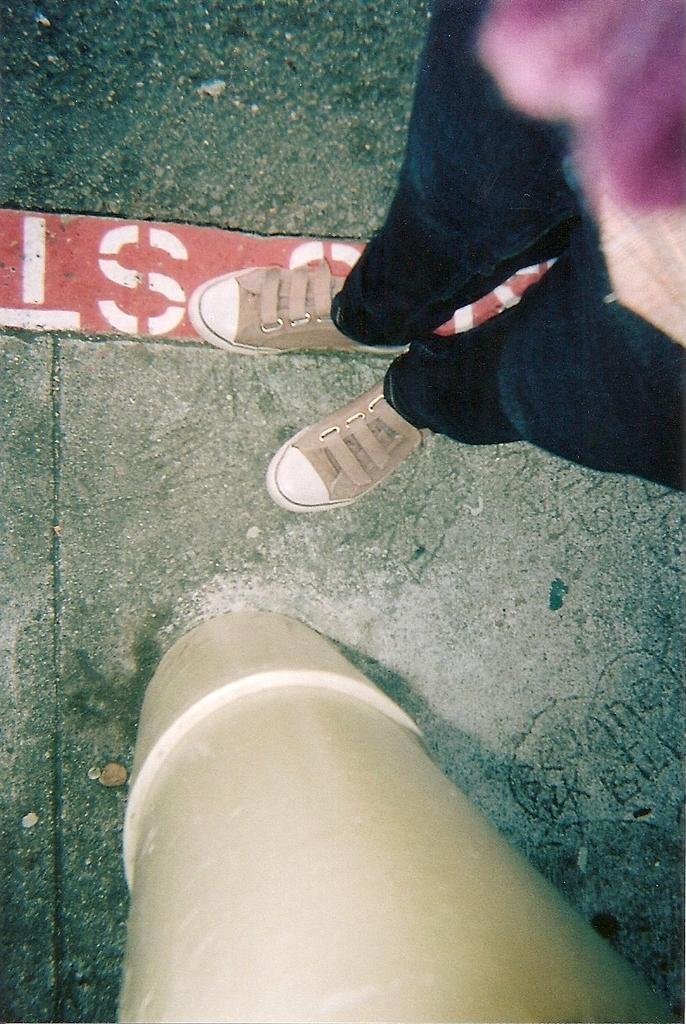What is the main subject of the image? The main subject of the image is a woman. What type of clothing is the woman wearing? The woman is wearing trousers, a top, and sneakers. What is the woman doing in the image? The woman is standing near a pole. What can be seen in the background of the image? There are red color bricks visible in the image. Can you tell me how many snakes are slithering around the woman's feet in the image? There are no snakes present in the image; the woman is standing near a pole with red color bricks in the background. What type of adjustment can be made to the faucet in the image? There is no faucet present in the image; it features a woman standing near a pole with red color bricks in the background. 